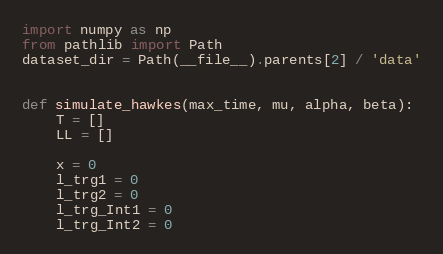Convert code to text. <code><loc_0><loc_0><loc_500><loc_500><_Python_>import numpy as np
from pathlib import Path
dataset_dir = Path(__file__).parents[2] / 'data'


def simulate_hawkes(max_time, mu, alpha, beta):
    T = []
    LL = []

    x = 0
    l_trg1 = 0
    l_trg2 = 0
    l_trg_Int1 = 0
    l_trg_Int2 = 0</code> 